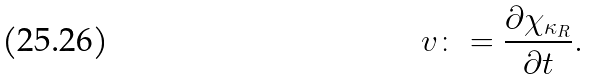Convert formula to latex. <formula><loc_0><loc_0><loc_500><loc_500>v \colon = \frac { \partial \chi _ { \kappa _ { R } } } { \partial t } .</formula> 